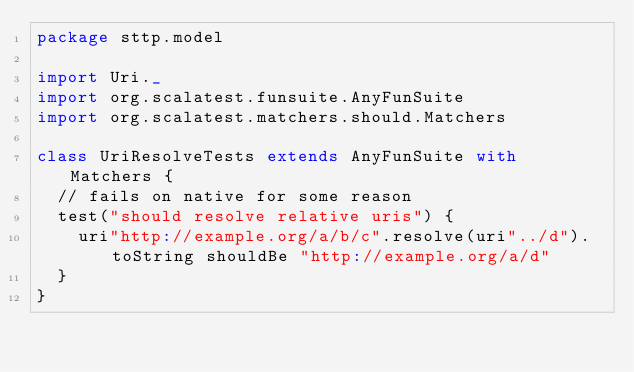Convert code to text. <code><loc_0><loc_0><loc_500><loc_500><_Scala_>package sttp.model

import Uri._
import org.scalatest.funsuite.AnyFunSuite
import org.scalatest.matchers.should.Matchers

class UriResolveTests extends AnyFunSuite with Matchers {
  // fails on native for some reason
  test("should resolve relative uris") {
    uri"http://example.org/a/b/c".resolve(uri"../d").toString shouldBe "http://example.org/a/d"
  }
}
</code> 